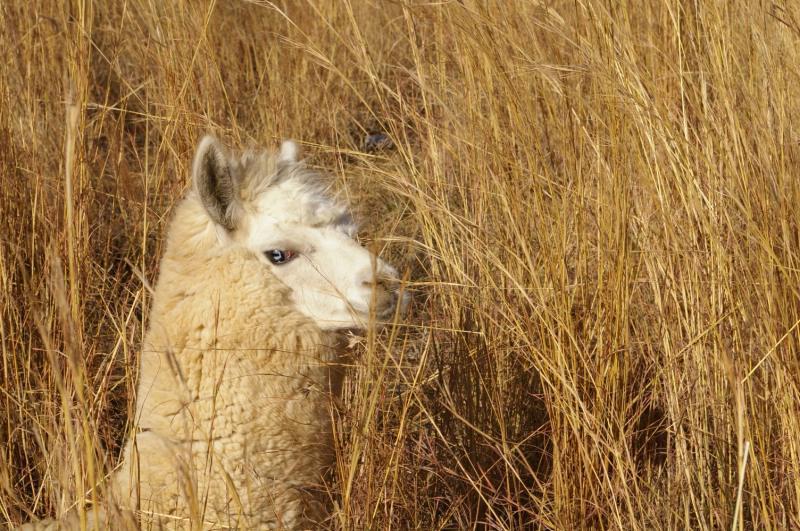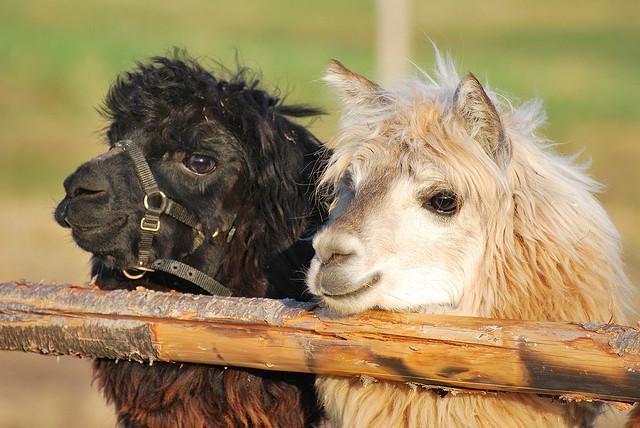The first image is the image on the left, the second image is the image on the right. Examine the images to the left and right. Is the description "An image shows two llamas, with the mouth of the one on the left touching the face of the one on the right." accurate? Answer yes or no. No. The first image is the image on the left, the second image is the image on the right. For the images displayed, is the sentence "The left and right image contains a total of four llamas." factually correct? Answer yes or no. No. 